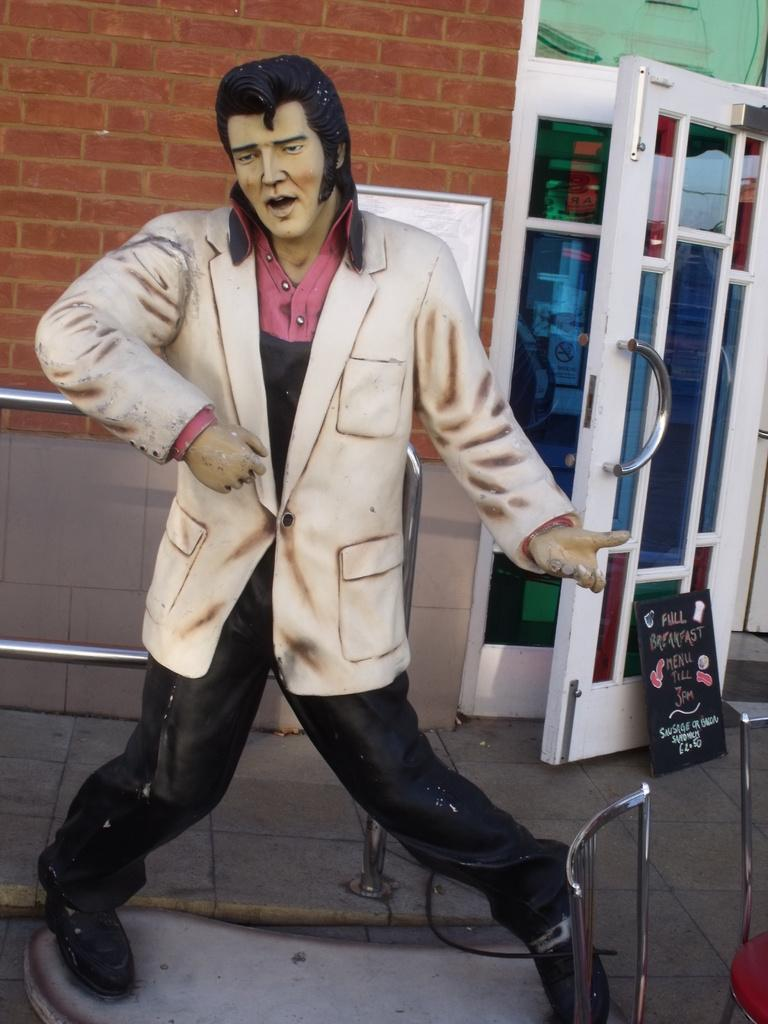What is the main subject in the center of the image? There is a statue in the center of the image. What can be seen in the background of the image? There is a wall, a fence, and a door in the background of the image. What type of stone is the statue made of in the image? The facts provided do not mention the type of stone the statue is made of, so it cannot be determined from the image. What kind of noise can be heard coming from the statue in the image? The image is static, so there is no noise associated with the statue or any other element in the image. 